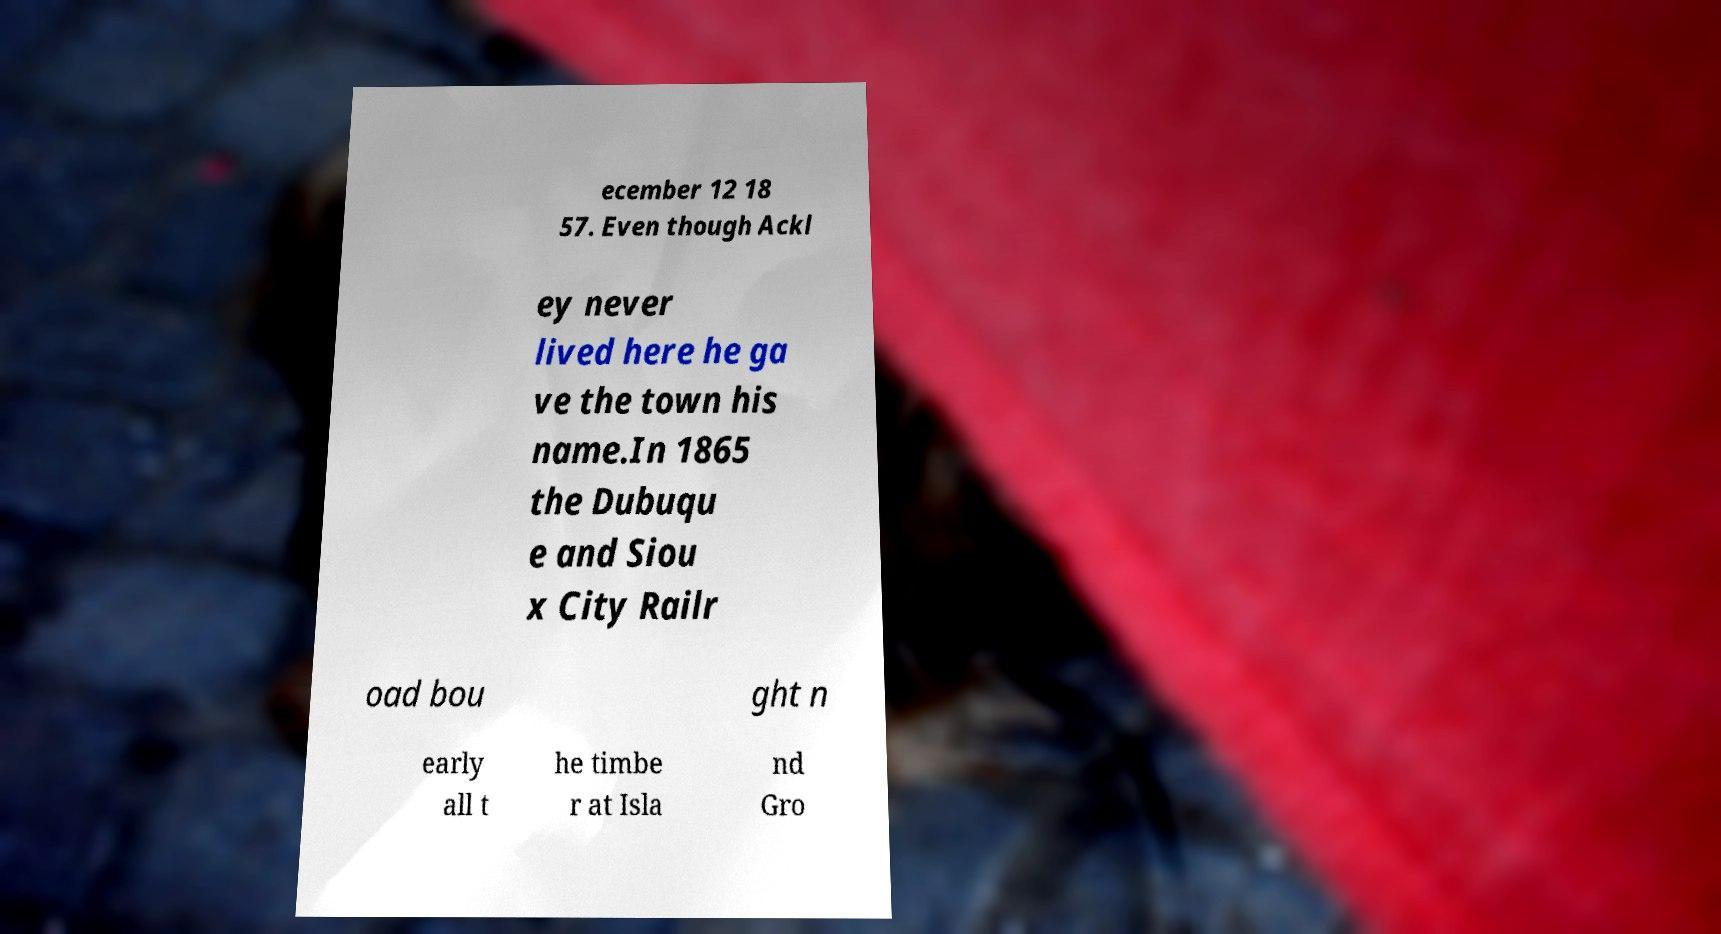I need the written content from this picture converted into text. Can you do that? ecember 12 18 57. Even though Ackl ey never lived here he ga ve the town his name.In 1865 the Dubuqu e and Siou x City Railr oad bou ght n early all t he timbe r at Isla nd Gro 